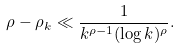<formula> <loc_0><loc_0><loc_500><loc_500>\rho - \rho _ { k } \ll \frac { 1 } { k ^ { \rho - 1 } ( \log k ) ^ { \rho } } .</formula> 